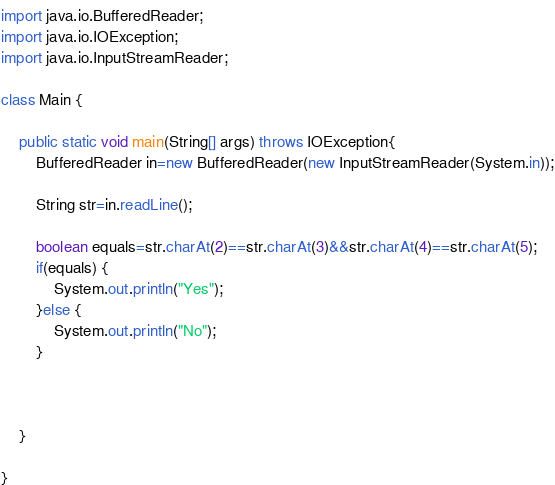Convert code to text. <code><loc_0><loc_0><loc_500><loc_500><_Java_>import java.io.BufferedReader;
import java.io.IOException;
import java.io.InputStreamReader;

class Main {

	public static void main(String[] args) throws IOException{
		BufferedReader in=new BufferedReader(new InputStreamReader(System.in));
		
		String str=in.readLine();
		
		boolean equals=str.charAt(2)==str.charAt(3)&&str.charAt(4)==str.charAt(5);
		if(equals) {
			System.out.println("Yes");
		}else {
			System.out.println("No");
		}
		
		

	}

}
</code> 